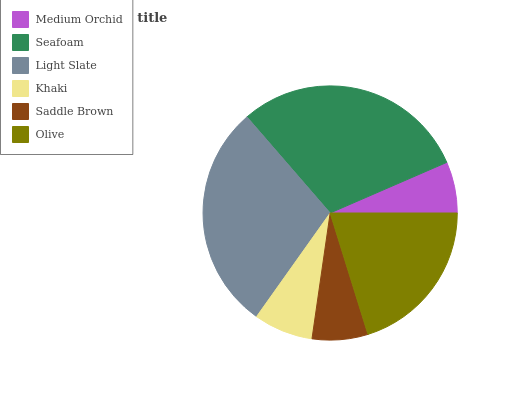Is Medium Orchid the minimum?
Answer yes or no. Yes. Is Seafoam the maximum?
Answer yes or no. Yes. Is Light Slate the minimum?
Answer yes or no. No. Is Light Slate the maximum?
Answer yes or no. No. Is Seafoam greater than Light Slate?
Answer yes or no. Yes. Is Light Slate less than Seafoam?
Answer yes or no. Yes. Is Light Slate greater than Seafoam?
Answer yes or no. No. Is Seafoam less than Light Slate?
Answer yes or no. No. Is Olive the high median?
Answer yes or no. Yes. Is Khaki the low median?
Answer yes or no. Yes. Is Saddle Brown the high median?
Answer yes or no. No. Is Saddle Brown the low median?
Answer yes or no. No. 